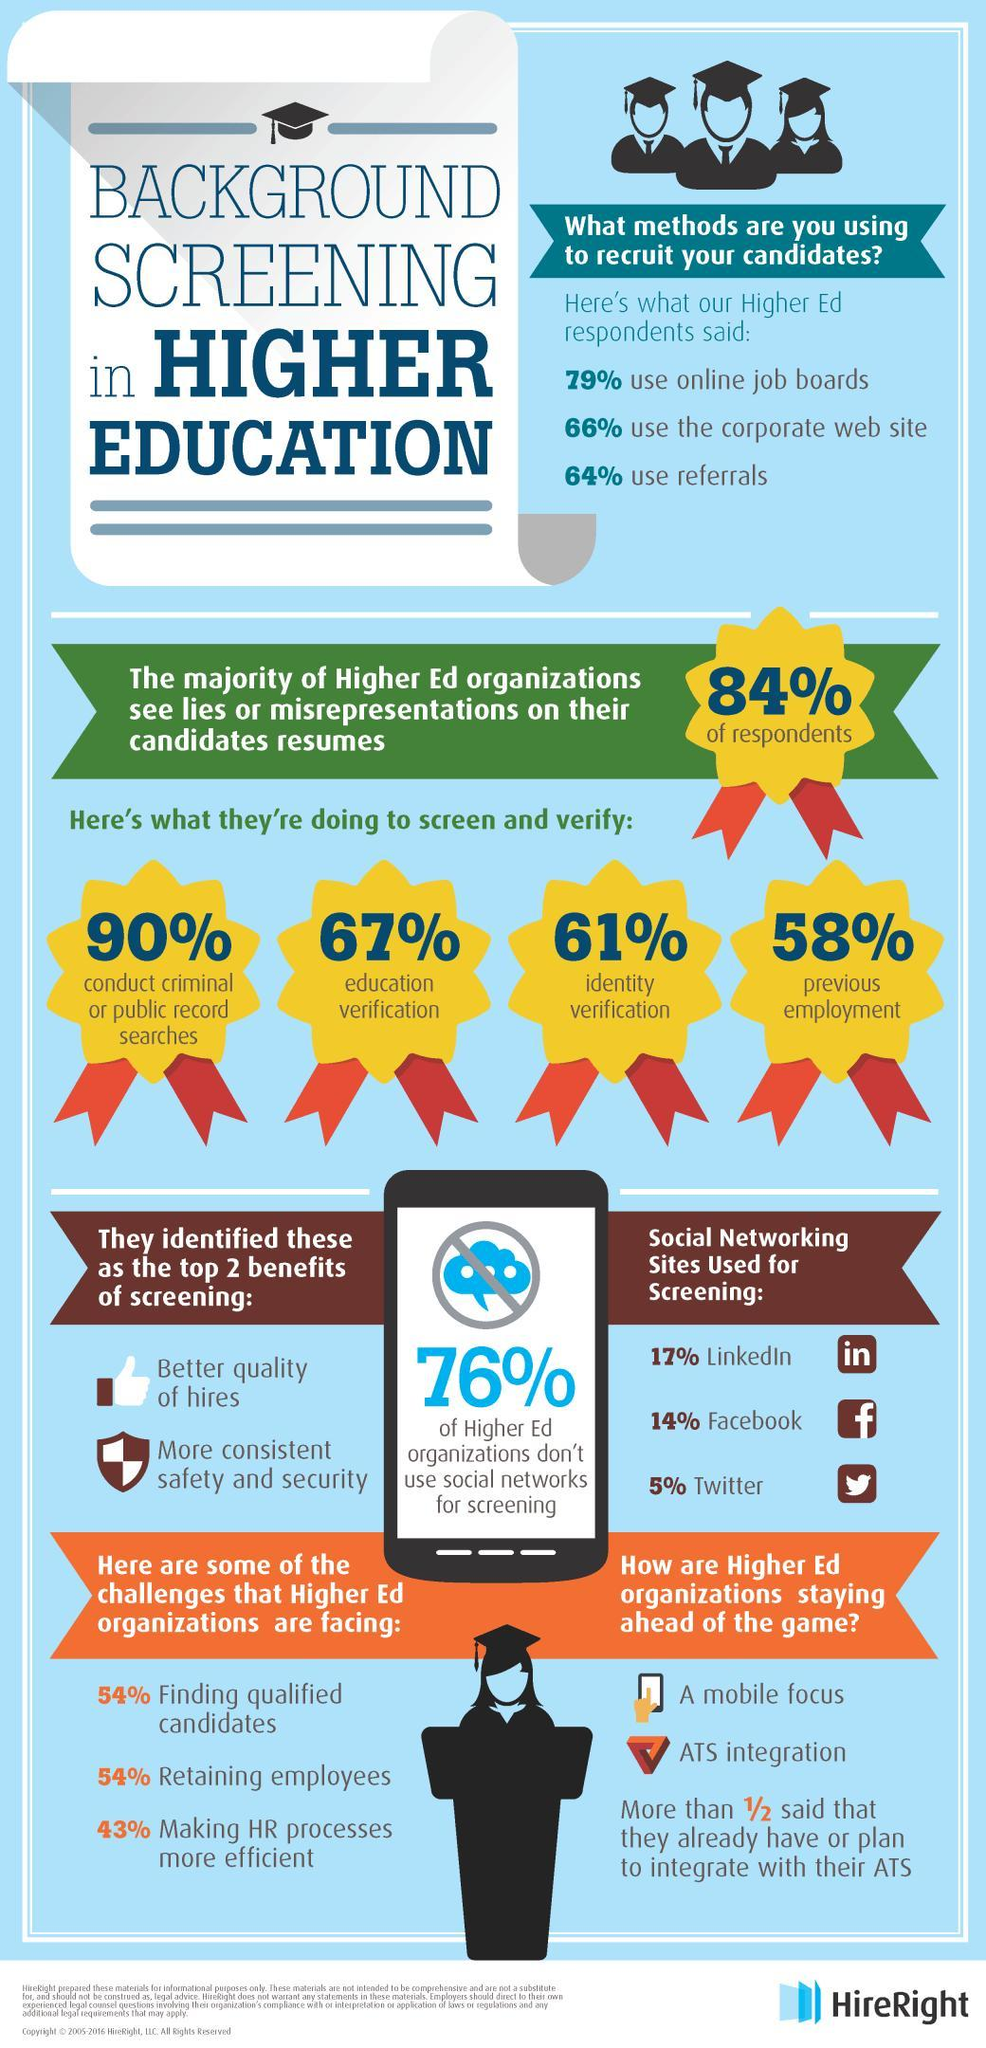Which social networking site is used by most recruiters?
Answer the question with a short phrase. LinkedIn What percentage of Higher Ed organizations use social networks for screening? 24 what percent of recruiters conduct criminal or public record searches? 90% What is the second benefit of screening mentioned? More consistent safety and security What is the second most used method to recruit candidates? use the corporate web site How many of the recruiters conduct identity verification? 61% How many of the recruiters check previous employment? 58% Which verification is done by 67% of recruiters? education verification How can better quality of hires be obtained? screening 